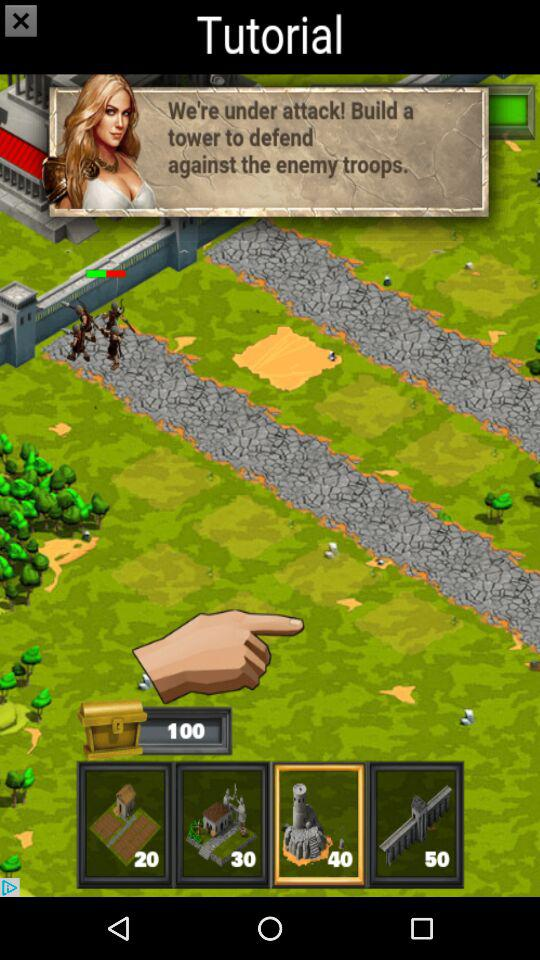What is the score?
When the provided information is insufficient, respond with <no answer>. <no answer> 